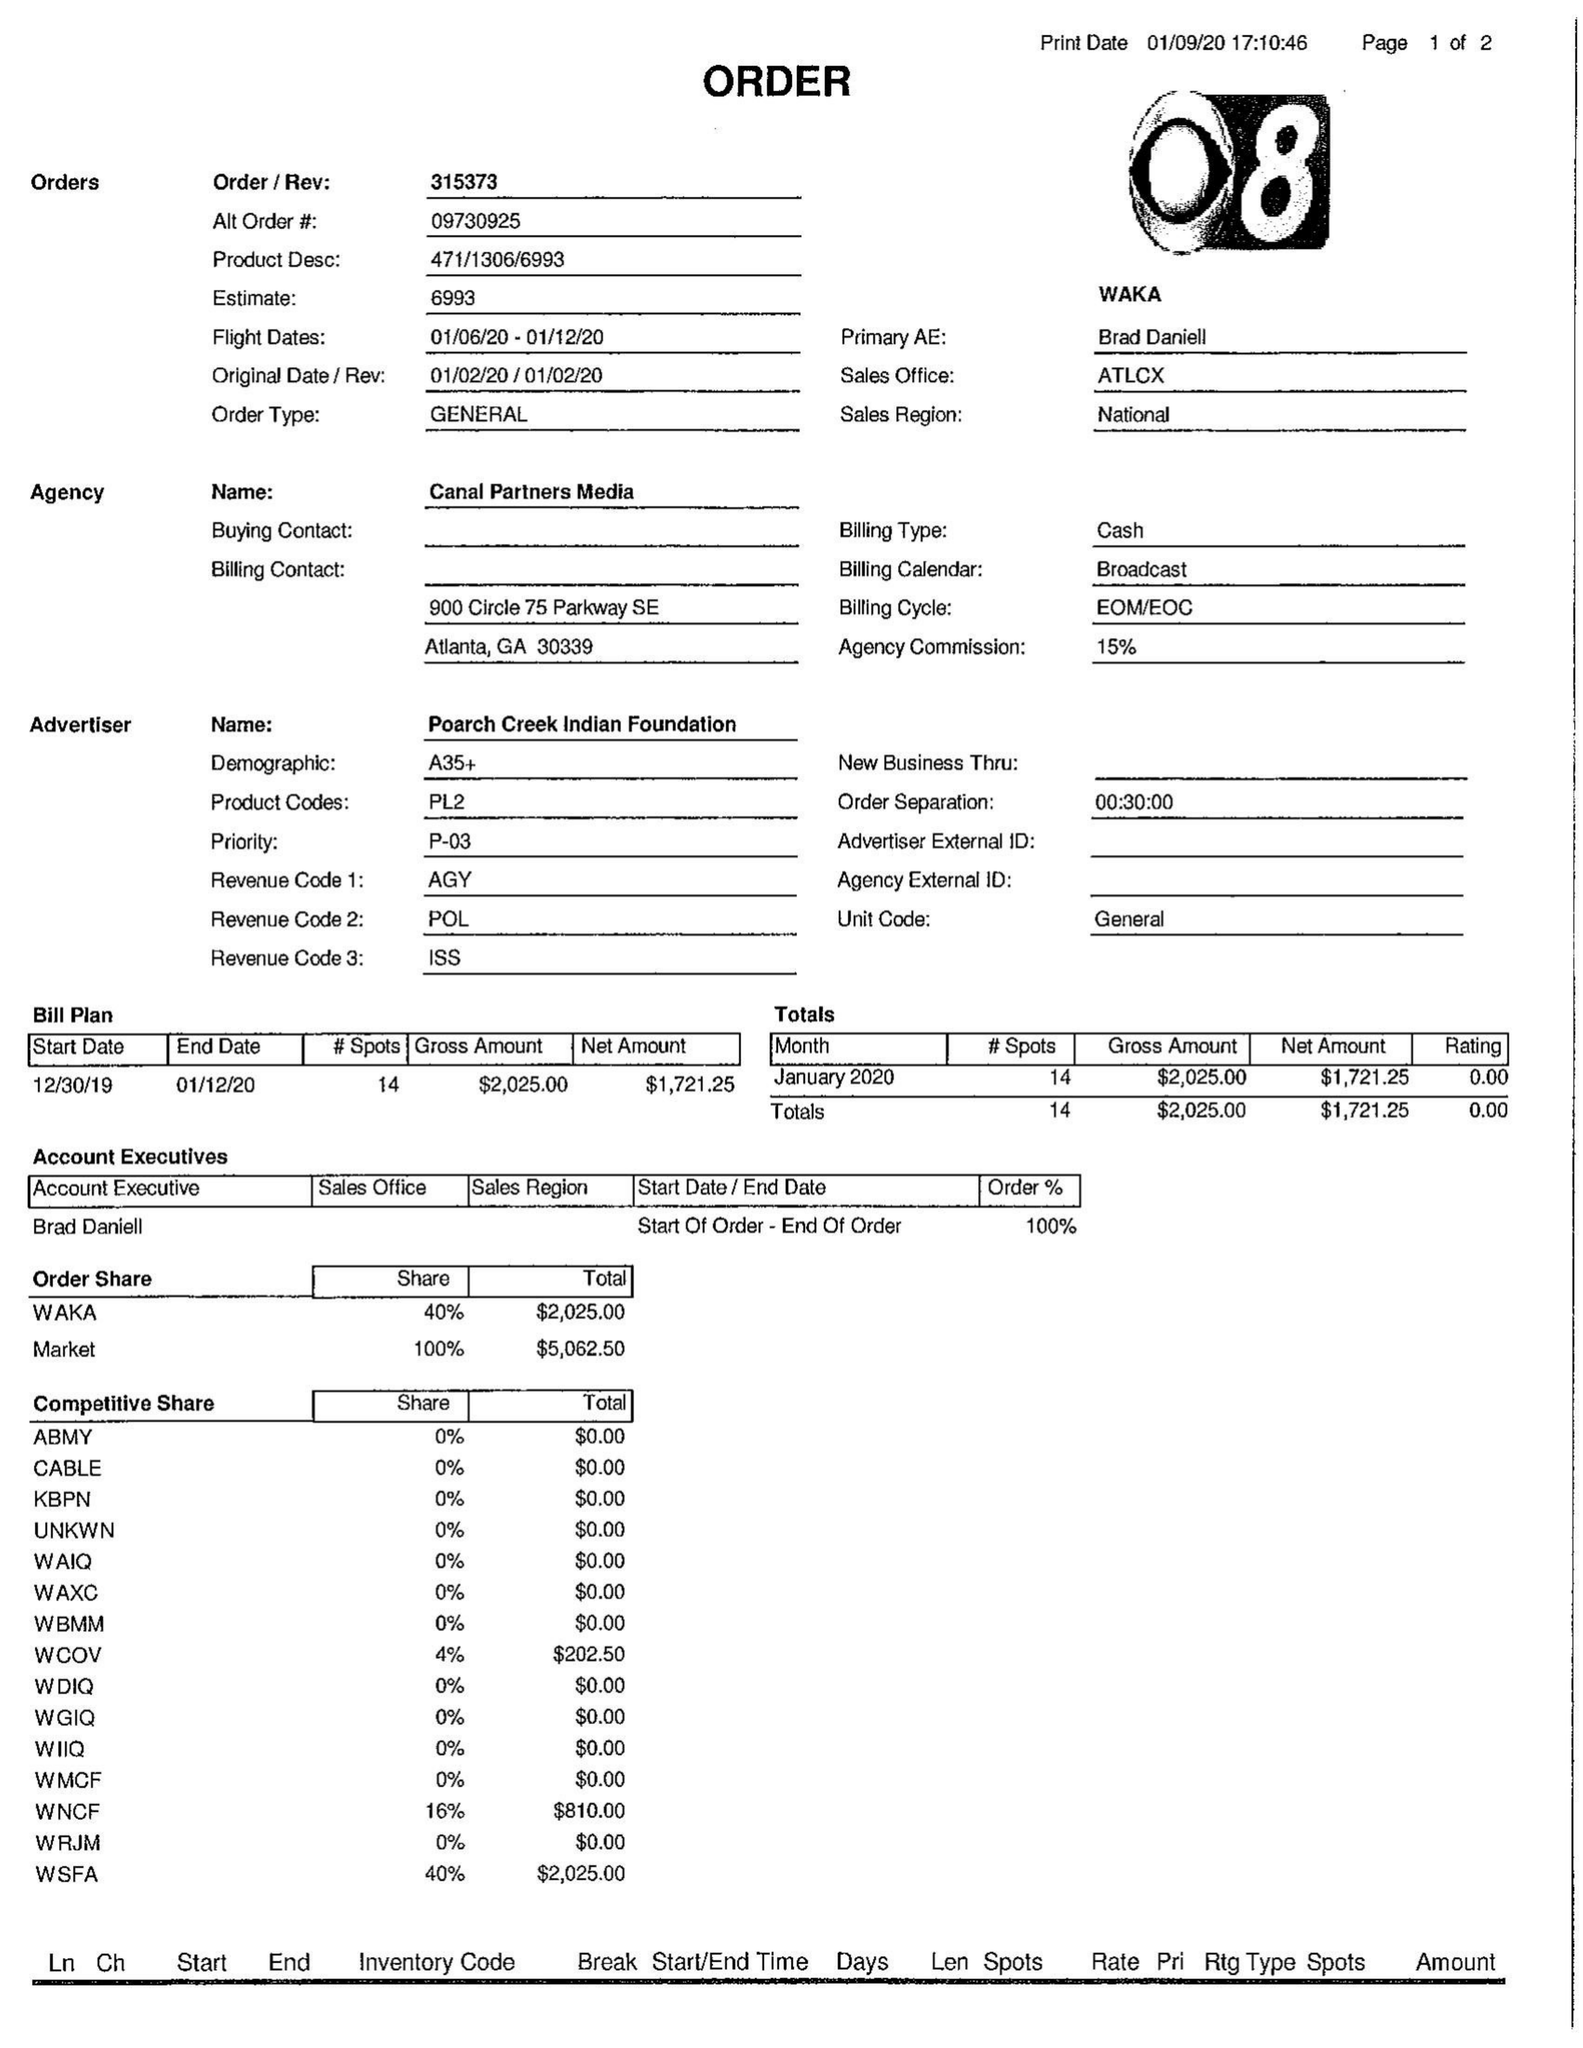What is the value for the flight_from?
Answer the question using a single word or phrase. 01/06/20 